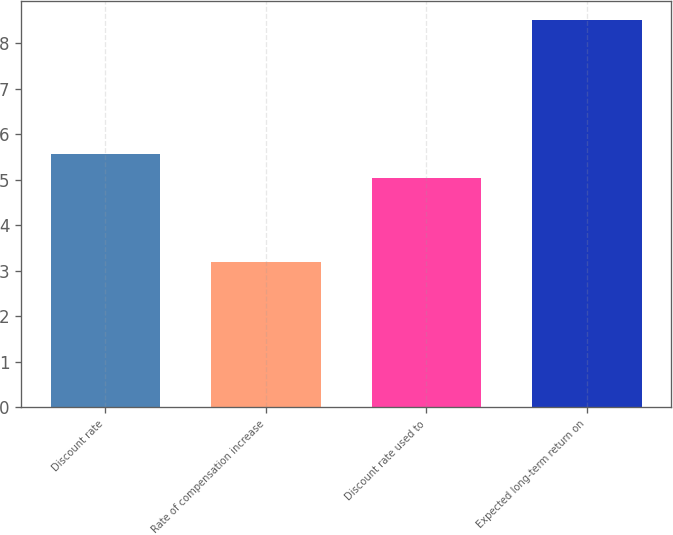<chart> <loc_0><loc_0><loc_500><loc_500><bar_chart><fcel>Discount rate<fcel>Rate of compensation increase<fcel>Discount rate used to<fcel>Expected long-term return on<nl><fcel>5.56<fcel>3.18<fcel>5.03<fcel>8.5<nl></chart> 